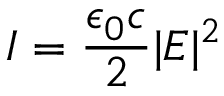Convert formula to latex. <formula><loc_0><loc_0><loc_500><loc_500>I = \frac { \epsilon _ { 0 } c } { 2 } | E | ^ { 2 }</formula> 